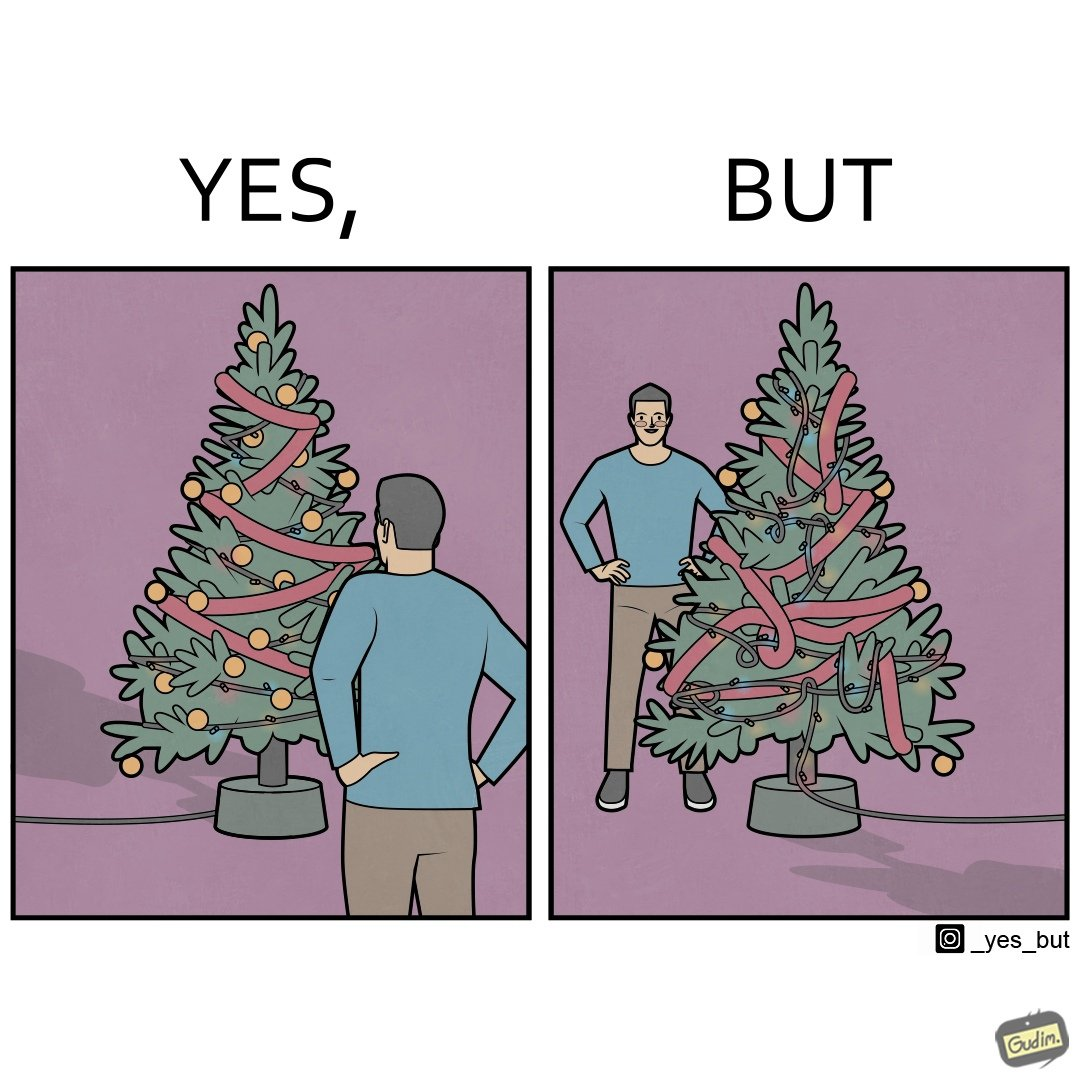Does this image contain satire or humor? Yes, this image is satirical. 